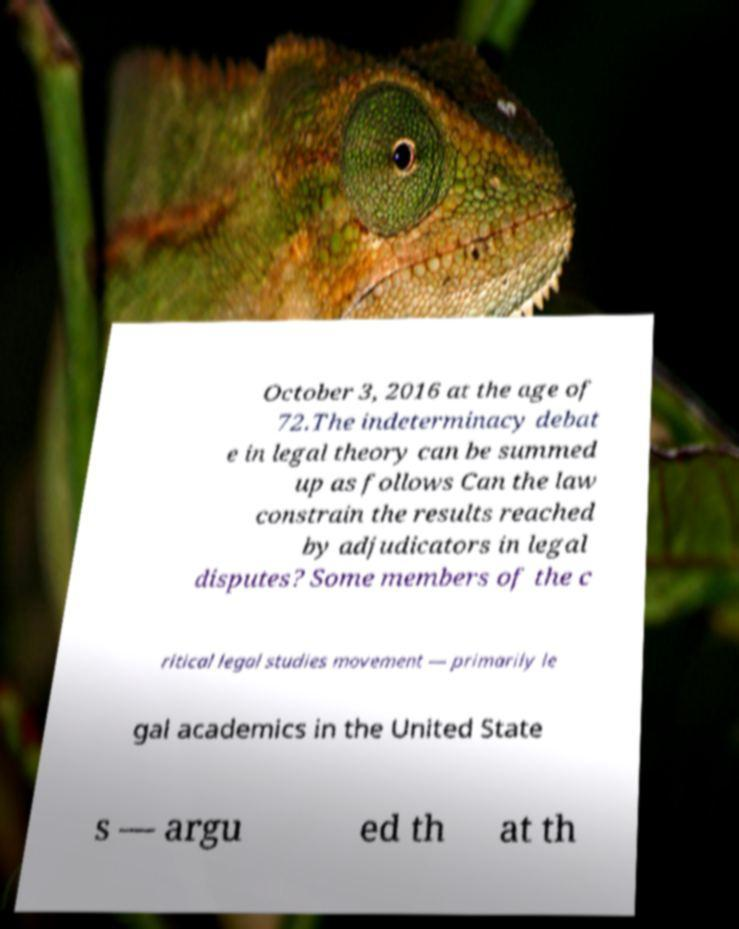What messages or text are displayed in this image? I need them in a readable, typed format. October 3, 2016 at the age of 72.The indeterminacy debat e in legal theory can be summed up as follows Can the law constrain the results reached by adjudicators in legal disputes? Some members of the c ritical legal studies movement — primarily le gal academics in the United State s — argu ed th at th 